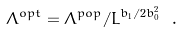Convert formula to latex. <formula><loc_0><loc_0><loc_500><loc_500>\Lambda ^ { o p t } = \Lambda ^ { p o p } / \bar { L } ^ { { b _ { 1 } } / 2 { b _ { 0 } ^ { 2 } } } \ .</formula> 